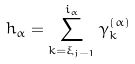Convert formula to latex. <formula><loc_0><loc_0><loc_500><loc_500>h _ { \alpha } = \sum _ { k = \xi _ { j - 1 } } ^ { i _ { \alpha } } \gamma ^ { ( \alpha ) } _ { k }</formula> 